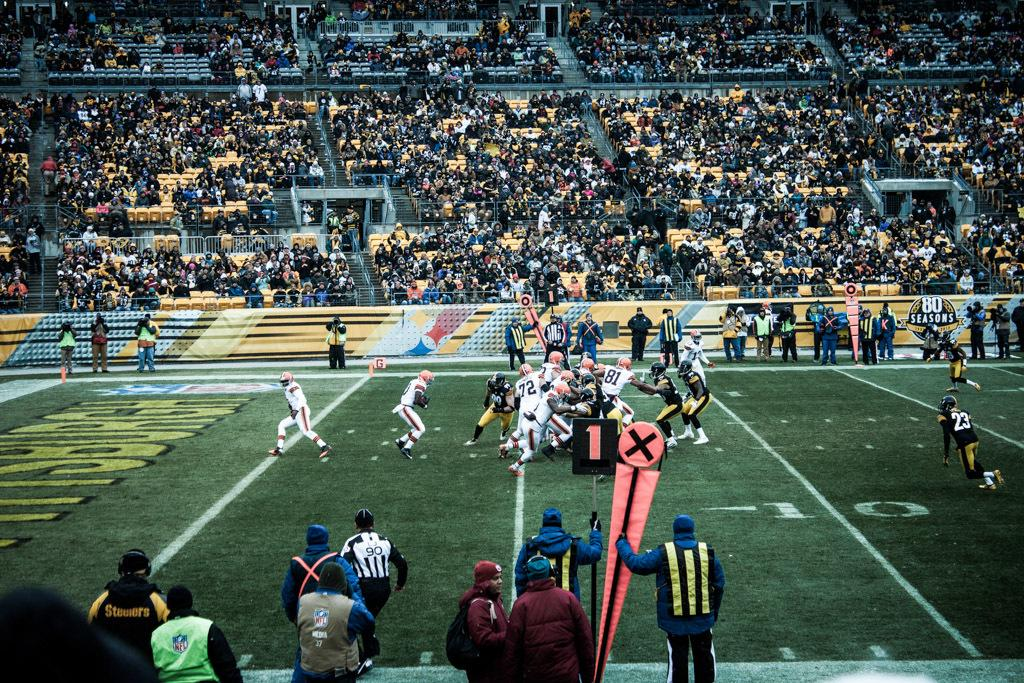<image>
Describe the image concisely. A football game where there are many players in the middle of the field they are at the 8 yard line. 